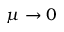Convert formula to latex. <formula><loc_0><loc_0><loc_500><loc_500>\mu \to 0</formula> 